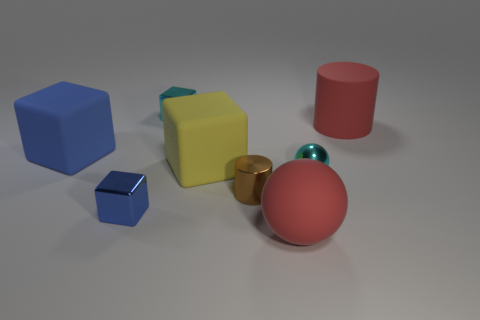What material is the cyan cube that is the same size as the blue metallic block?
Give a very brief answer. Metal. Are there the same number of balls that are behind the small cyan metallic cube and red cylinders right of the small brown shiny cylinder?
Your answer should be compact. No. There is a large block that is on the left side of the small cube in front of the brown thing; how many cylinders are behind it?
Keep it short and to the point. 1. There is a large rubber ball; is its color the same as the tiny shiny thing that is on the right side of the large ball?
Offer a very short reply. No. The blue block that is made of the same material as the red sphere is what size?
Your answer should be very brief. Large. Is the number of big matte cubes that are in front of the big red ball greater than the number of metal cylinders?
Offer a terse response. No. What is the material of the sphere in front of the brown object in front of the big red thing right of the large ball?
Your response must be concise. Rubber. Are the cyan block and the cyan thing in front of the yellow matte block made of the same material?
Your answer should be very brief. Yes. There is a large thing that is the same shape as the tiny brown thing; what is its material?
Your answer should be very brief. Rubber. Is there anything else that has the same material as the cyan block?
Ensure brevity in your answer.  Yes. 